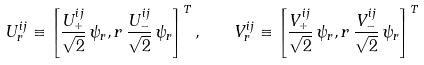Convert formula to latex. <formula><loc_0><loc_0><loc_500><loc_500>U _ { r } ^ { i j } \equiv \left [ \frac { U _ { + } ^ { i j } } { \sqrt { 2 } } \, \psi _ { r } , r \, \frac { U _ { - } ^ { i j } } { \sqrt { 2 } } \, \psi _ { r } \right ] ^ { T } , \quad V _ { r } ^ { i j } \equiv \left [ \frac { V _ { + } ^ { i j } } { \sqrt { 2 } } \, \psi _ { r } , r \, \frac { V _ { - } ^ { i j } } { \sqrt { 2 } } \, \psi _ { r } \right ] ^ { T }</formula> 